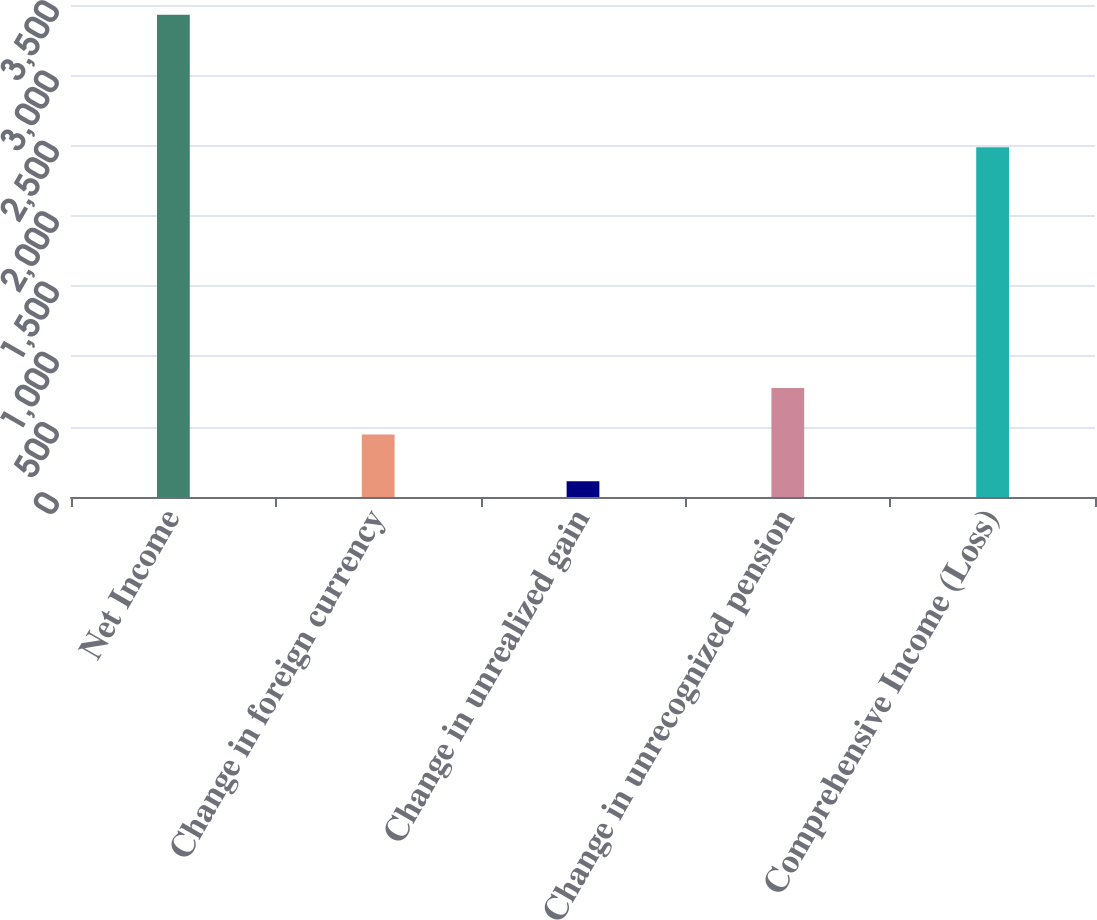<chart> <loc_0><loc_0><loc_500><loc_500><bar_chart><fcel>Net Income<fcel>Change in foreign currency<fcel>Change in unrealized gain<fcel>Change in unrecognized pension<fcel>Comprehensive Income (Loss)<nl><fcel>3431<fcel>443.9<fcel>112<fcel>775.8<fcel>2488<nl></chart> 